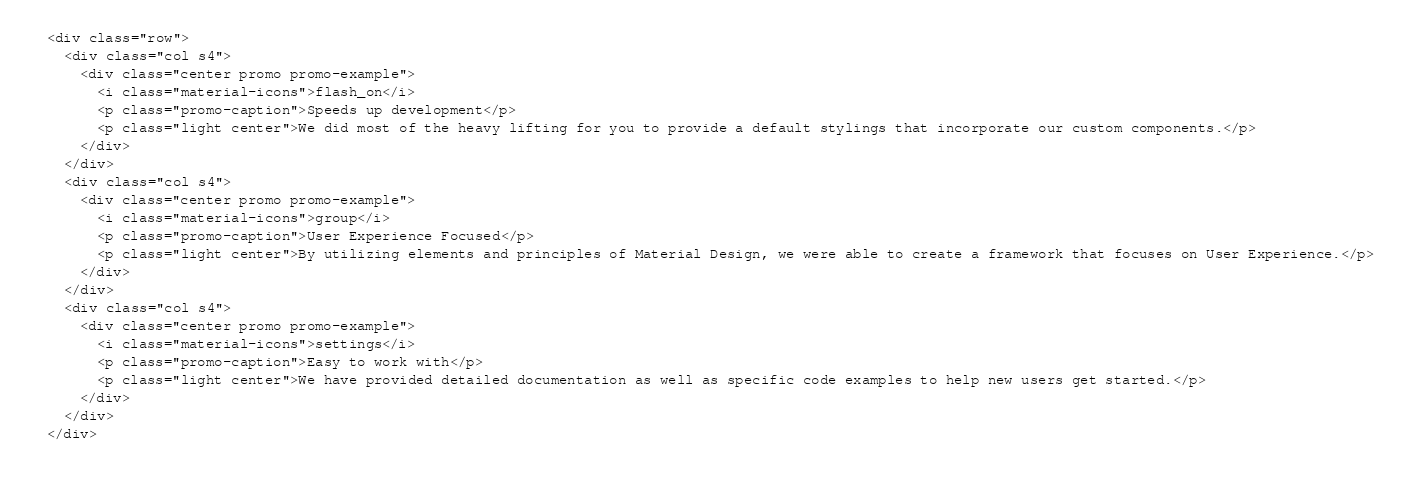<code> <loc_0><loc_0><loc_500><loc_500><_PHP_>
  <div class="row">
    <div class="col s4">
      <div class="center promo promo-example">
        <i class="material-icons">flash_on</i>
        <p class="promo-caption">Speeds up development</p>
        <p class="light center">We did most of the heavy lifting for you to provide a default stylings that incorporate our custom components.</p>
      </div>
    </div>
    <div class="col s4">
      <div class="center promo promo-example">
        <i class="material-icons">group</i>
        <p class="promo-caption">User Experience Focused</p>
        <p class="light center">By utilizing elements and principles of Material Design, we were able to create a framework that focuses on User Experience.</p>
      </div>
    </div>
    <div class="col s4">
      <div class="center promo promo-example">
        <i class="material-icons">settings</i>
        <p class="promo-caption">Easy to work with</p>
        <p class="light center">We have provided detailed documentation as well as specific code examples to help new users get started.</p>
      </div>
    </div>
  </div>
  
</code> 